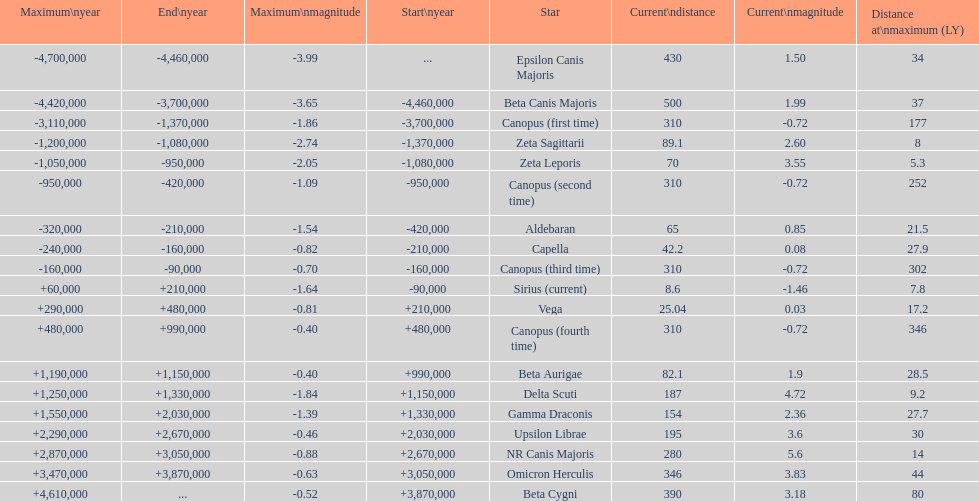How many stars have a distance at maximum of 30 light years or higher? 9. 